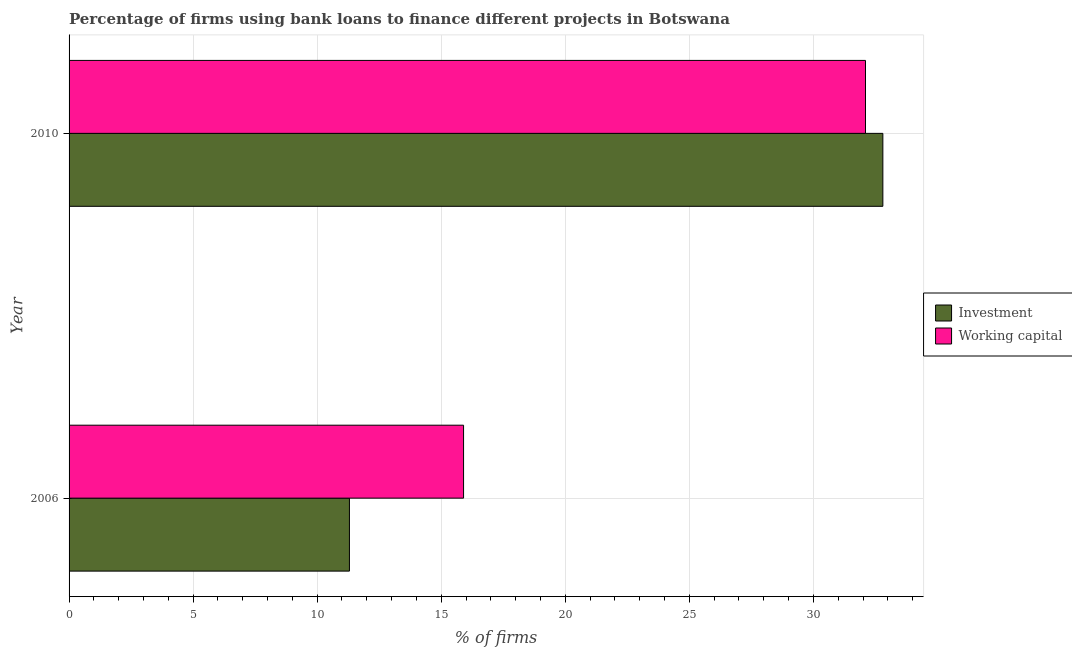How many different coloured bars are there?
Ensure brevity in your answer.  2. How many groups of bars are there?
Your response must be concise. 2. How many bars are there on the 2nd tick from the bottom?
Your response must be concise. 2. What is the label of the 2nd group of bars from the top?
Give a very brief answer. 2006. In how many cases, is the number of bars for a given year not equal to the number of legend labels?
Give a very brief answer. 0. What is the percentage of firms using banks to finance investment in 2010?
Ensure brevity in your answer.  32.8. Across all years, what is the maximum percentage of firms using banks to finance investment?
Keep it short and to the point. 32.8. Across all years, what is the minimum percentage of firms using banks to finance investment?
Provide a succinct answer. 11.3. In which year was the percentage of firms using banks to finance working capital maximum?
Offer a terse response. 2010. What is the total percentage of firms using banks to finance investment in the graph?
Offer a terse response. 44.1. What is the difference between the percentage of firms using banks to finance investment in 2006 and that in 2010?
Provide a succinct answer. -21.5. What is the average percentage of firms using banks to finance investment per year?
Provide a short and direct response. 22.05. In the year 2010, what is the difference between the percentage of firms using banks to finance investment and percentage of firms using banks to finance working capital?
Provide a succinct answer. 0.7. In how many years, is the percentage of firms using banks to finance investment greater than 30 %?
Make the answer very short. 1. What is the ratio of the percentage of firms using banks to finance investment in 2006 to that in 2010?
Make the answer very short. 0.34. Is the percentage of firms using banks to finance investment in 2006 less than that in 2010?
Your answer should be compact. Yes. What does the 1st bar from the top in 2006 represents?
Your response must be concise. Working capital. What does the 2nd bar from the bottom in 2006 represents?
Keep it short and to the point. Working capital. Are all the bars in the graph horizontal?
Make the answer very short. Yes. How many years are there in the graph?
Your answer should be very brief. 2. Are the values on the major ticks of X-axis written in scientific E-notation?
Make the answer very short. No. Does the graph contain any zero values?
Keep it short and to the point. No. Does the graph contain grids?
Offer a terse response. Yes. What is the title of the graph?
Ensure brevity in your answer.  Percentage of firms using bank loans to finance different projects in Botswana. Does "Canada" appear as one of the legend labels in the graph?
Your answer should be very brief. No. What is the label or title of the X-axis?
Your answer should be very brief. % of firms. What is the % of firms in Investment in 2010?
Your response must be concise. 32.8. What is the % of firms of Working capital in 2010?
Provide a short and direct response. 32.1. Across all years, what is the maximum % of firms of Investment?
Your answer should be compact. 32.8. Across all years, what is the maximum % of firms in Working capital?
Make the answer very short. 32.1. Across all years, what is the minimum % of firms of Investment?
Offer a terse response. 11.3. Across all years, what is the minimum % of firms in Working capital?
Make the answer very short. 15.9. What is the total % of firms in Investment in the graph?
Your answer should be compact. 44.1. What is the total % of firms of Working capital in the graph?
Your answer should be compact. 48. What is the difference between the % of firms of Investment in 2006 and that in 2010?
Your response must be concise. -21.5. What is the difference between the % of firms of Working capital in 2006 and that in 2010?
Offer a terse response. -16.2. What is the difference between the % of firms in Investment in 2006 and the % of firms in Working capital in 2010?
Your response must be concise. -20.8. What is the average % of firms of Investment per year?
Your answer should be compact. 22.05. In the year 2010, what is the difference between the % of firms in Investment and % of firms in Working capital?
Make the answer very short. 0.7. What is the ratio of the % of firms in Investment in 2006 to that in 2010?
Ensure brevity in your answer.  0.34. What is the ratio of the % of firms of Working capital in 2006 to that in 2010?
Keep it short and to the point. 0.5. What is the difference between the highest and the lowest % of firms of Investment?
Provide a short and direct response. 21.5. What is the difference between the highest and the lowest % of firms in Working capital?
Provide a short and direct response. 16.2. 